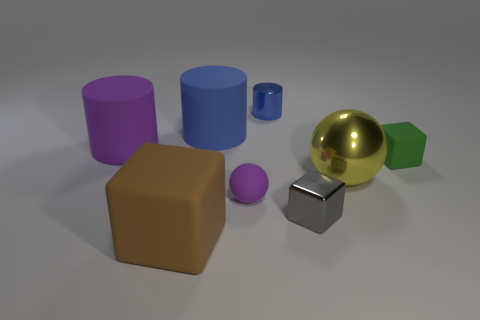Add 1 purple things. How many objects exist? 9 Subtract all balls. How many objects are left? 6 Subtract 0 cyan cylinders. How many objects are left? 8 Subtract all purple things. Subtract all tiny purple cubes. How many objects are left? 6 Add 5 big cylinders. How many big cylinders are left? 7 Add 2 cyan metallic cubes. How many cyan metallic cubes exist? 2 